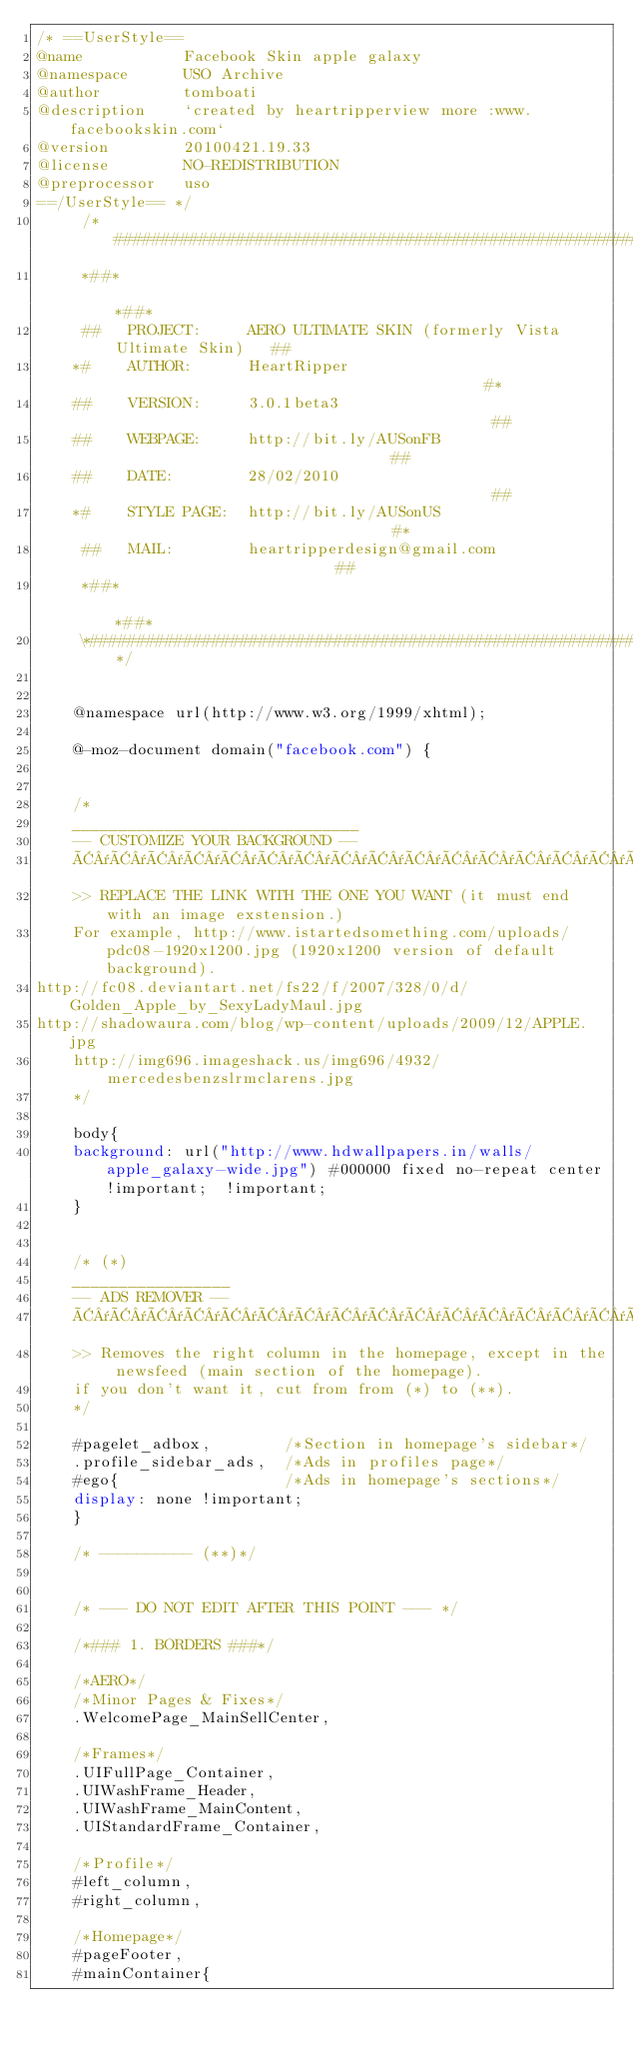<code> <loc_0><loc_0><loc_500><loc_500><_CSS_>/* ==UserStyle==
@name           Facebook Skin apple galaxy
@namespace      USO Archive
@author         tomboati
@description    `created by heartripperview more :www.facebookskin.com`
@version        20100421.19.33
@license        NO-REDISTRIBUTION
@preprocessor   uso
==/UserStyle== */
	 /*####################################################################*\  
	 *##*                                                                *##*
	 ##   PROJECT:     AERO ULTIMATE SKIN (formerly Vista Ultimate Skin)   ##
	*#    AUTHOR:      HeartRipper                                          #*
	##    VERSION:     3.0.1beta3                                           ##
	##    WEBPAGE:     http://bit.ly/AUSonFB                                ##
	##    DATE:        28/02/2010                                           ##  
	*#    STYLE PAGE:  http://bit.ly/AUSonUS                                #*
	 ##   MAIL:        heartripperdesign@gmail.com                         ##
	 *##*                                                                *##*
	 \*####################################################################*/


	@namespace url(http://www.w3.org/1999/xhtml);

	@-moz-document domain("facebook.com") {


	/*
	_______________________________
	-- CUSTOMIZE YOUR BACKGROUND --
	Â¯Â¯Â¯Â¯Â¯Â¯Â¯Â¯Â¯Â¯Â¯Â¯Â¯Â¯Â¯Â¯Â¯Â¯Â¯Â¯Â¯Â¯Â¯Â¯Â¯Â¯Â¯Â¯Â¯Â¯Â¯
	>> REPLACE THE LINK WITH THE ONE YOU WANT (it must end with an image exstension.)
	For example, http://www.istartedsomething.com/uploads/pdc08-1920x1200.jpg (1920x1200 version of default background).
http://fc08.deviantart.net/fs22/f/2007/328/0/d/Golden_Apple_by_SexyLadyMaul.jpg
http://shadowaura.com/blog/wp-content/uploads/2009/12/APPLE.jpg
	http://img696.imageshack.us/img696/4932/mercedesbenzslrmclarens.jpg
	*/

	body{
	background: url("http://www.hdwallpapers.in/walls/apple_galaxy-wide.jpg") #000000 fixed no-repeat center!important;  !important;
	}


	/* (*)
	_________________
	-- ADS REMOVER -- 
	Â¯Â¯Â¯Â¯Â¯Â¯Â¯Â¯Â¯Â¯Â¯Â¯Â¯Â¯Â¯Â¯Â¯
	>> Removes the right column in the homepage, except in the newsfeed (main section of the homepage).
	if you don't want it, cut from from (*) to (**).
	*/

	#pagelet_adbox,        /*Section in homepage's sidebar*/
	.profile_sidebar_ads,  /*Ads in profiles page*/
	#ego{                  /*Ads in homepage's sections*/
	display: none !important;
	}

	/* ---------- (**)*/


	/* --- DO NOT EDIT AFTER THIS POINT --- */

	/*### 1. BORDERS ###*/

	/*AERO*/
	/*Minor Pages & Fixes*/
	.WelcomePage_MainSellCenter,

	/*Frames*/
	.UIFullPage_Container,
	.UIWashFrame_Header,
	.UIWashFrame_MainContent,
	.UIStandardFrame_Container,

	/*Profile*/
	#left_column,
	#right_column,

	/*Homepage*/
	#pageFooter,
	#mainContainer{</code> 